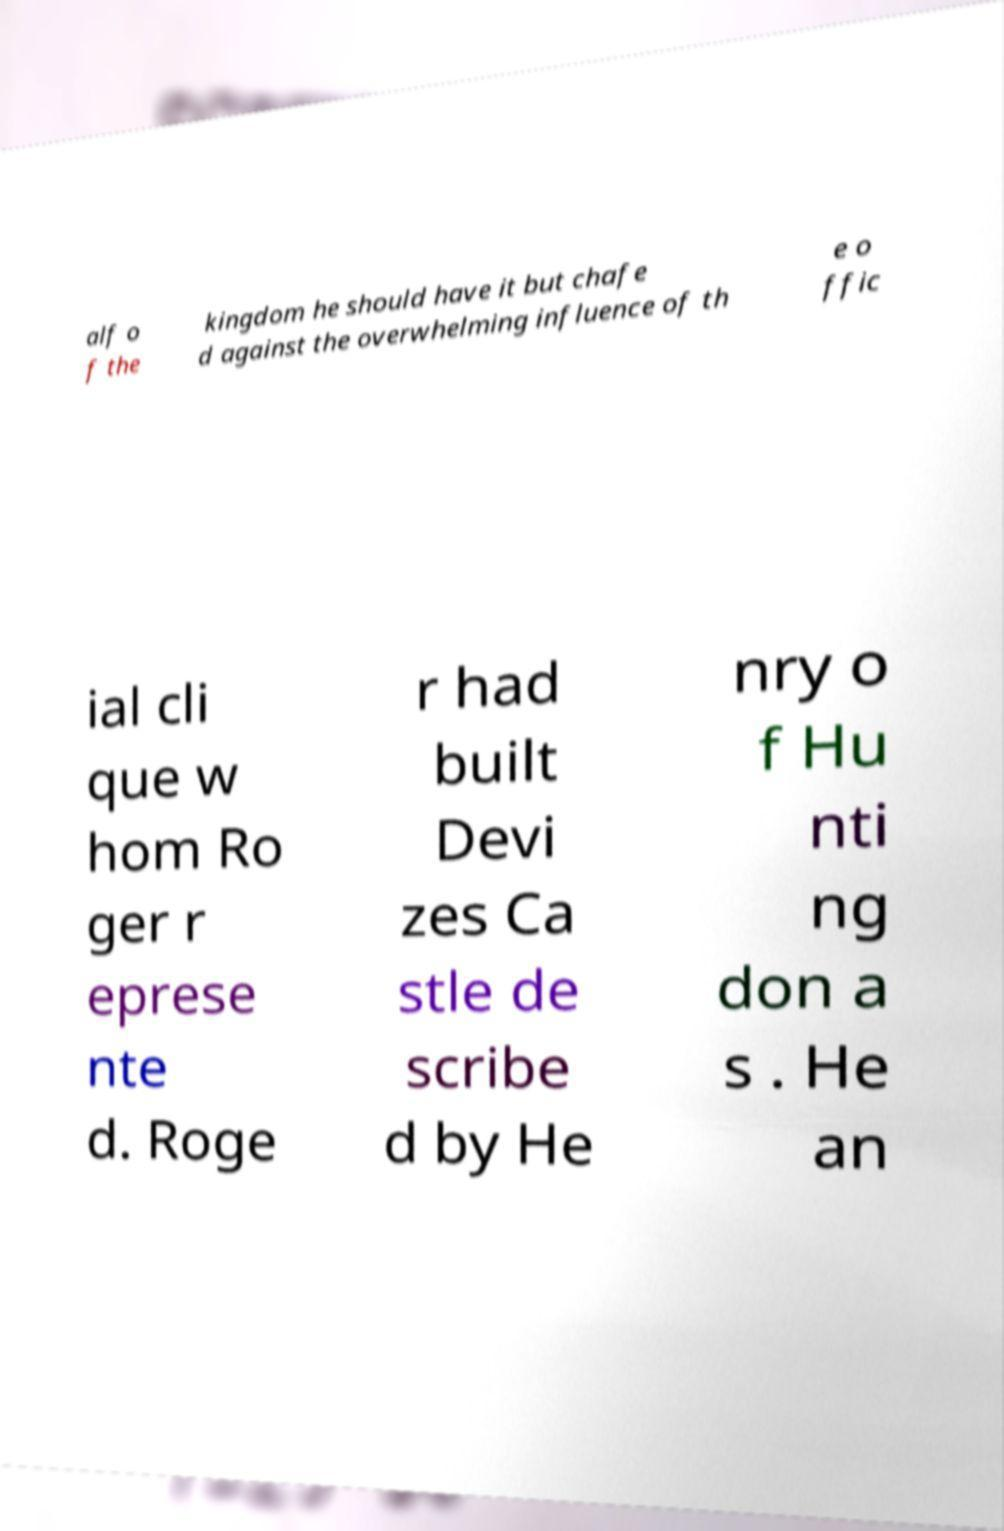Could you extract and type out the text from this image? alf o f the kingdom he should have it but chafe d against the overwhelming influence of th e o ffic ial cli que w hom Ro ger r eprese nte d. Roge r had built Devi zes Ca stle de scribe d by He nry o f Hu nti ng don a s . He an 